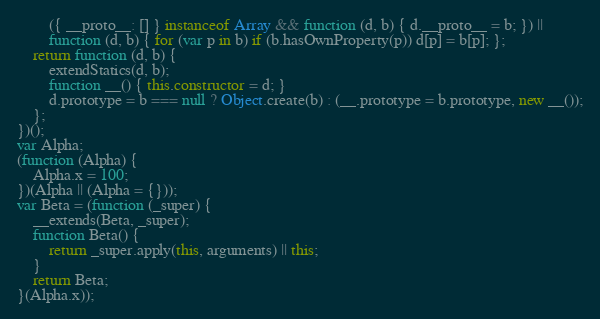Convert code to text. <code><loc_0><loc_0><loc_500><loc_500><_JavaScript_>        ({ __proto__: [] } instanceof Array && function (d, b) { d.__proto__ = b; }) ||
        function (d, b) { for (var p in b) if (b.hasOwnProperty(p)) d[p] = b[p]; };
    return function (d, b) {
        extendStatics(d, b);
        function __() { this.constructor = d; }
        d.prototype = b === null ? Object.create(b) : (__.prototype = b.prototype, new __());
    };
})();
var Alpha;
(function (Alpha) {
    Alpha.x = 100;
})(Alpha || (Alpha = {}));
var Beta = (function (_super) {
    __extends(Beta, _super);
    function Beta() {
        return _super.apply(this, arguments) || this;
    }
    return Beta;
}(Alpha.x));
</code> 